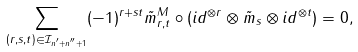Convert formula to latex. <formula><loc_0><loc_0><loc_500><loc_500>\sum _ { ( r , s , t ) \in \mathcal { I } _ { n ^ { \prime } + n ^ { \prime \prime } + 1 } } ( - 1 ) ^ { r + s t } \tilde { m } _ { r , t } ^ { M } \circ ( i d ^ { \otimes r } \otimes \tilde { m } _ { s } \otimes i d ^ { \otimes t } ) = 0 ,</formula> 